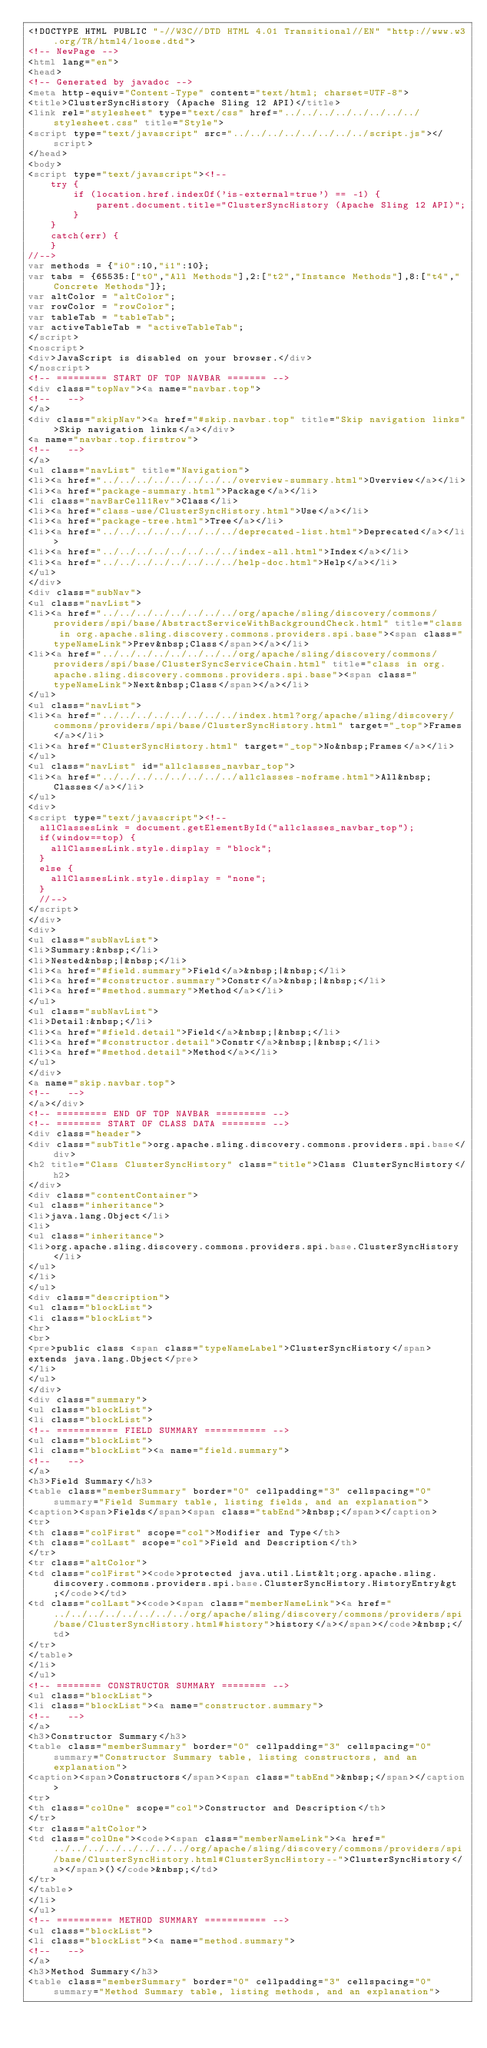<code> <loc_0><loc_0><loc_500><loc_500><_HTML_><!DOCTYPE HTML PUBLIC "-//W3C//DTD HTML 4.01 Transitional//EN" "http://www.w3.org/TR/html4/loose.dtd">
<!-- NewPage -->
<html lang="en">
<head>
<!-- Generated by javadoc -->
<meta http-equiv="Content-Type" content="text/html; charset=UTF-8">
<title>ClusterSyncHistory (Apache Sling 12 API)</title>
<link rel="stylesheet" type="text/css" href="../../../../../../../../stylesheet.css" title="Style">
<script type="text/javascript" src="../../../../../../../../script.js"></script>
</head>
<body>
<script type="text/javascript"><!--
    try {
        if (location.href.indexOf('is-external=true') == -1) {
            parent.document.title="ClusterSyncHistory (Apache Sling 12 API)";
        }
    }
    catch(err) {
    }
//-->
var methods = {"i0":10,"i1":10};
var tabs = {65535:["t0","All Methods"],2:["t2","Instance Methods"],8:["t4","Concrete Methods"]};
var altColor = "altColor";
var rowColor = "rowColor";
var tableTab = "tableTab";
var activeTableTab = "activeTableTab";
</script>
<noscript>
<div>JavaScript is disabled on your browser.</div>
</noscript>
<!-- ========= START OF TOP NAVBAR ======= -->
<div class="topNav"><a name="navbar.top">
<!--   -->
</a>
<div class="skipNav"><a href="#skip.navbar.top" title="Skip navigation links">Skip navigation links</a></div>
<a name="navbar.top.firstrow">
<!--   -->
</a>
<ul class="navList" title="Navigation">
<li><a href="../../../../../../../../overview-summary.html">Overview</a></li>
<li><a href="package-summary.html">Package</a></li>
<li class="navBarCell1Rev">Class</li>
<li><a href="class-use/ClusterSyncHistory.html">Use</a></li>
<li><a href="package-tree.html">Tree</a></li>
<li><a href="../../../../../../../../deprecated-list.html">Deprecated</a></li>
<li><a href="../../../../../../../../index-all.html">Index</a></li>
<li><a href="../../../../../../../../help-doc.html">Help</a></li>
</ul>
</div>
<div class="subNav">
<ul class="navList">
<li><a href="../../../../../../../../org/apache/sling/discovery/commons/providers/spi/base/AbstractServiceWithBackgroundCheck.html" title="class in org.apache.sling.discovery.commons.providers.spi.base"><span class="typeNameLink">Prev&nbsp;Class</span></a></li>
<li><a href="../../../../../../../../org/apache/sling/discovery/commons/providers/spi/base/ClusterSyncServiceChain.html" title="class in org.apache.sling.discovery.commons.providers.spi.base"><span class="typeNameLink">Next&nbsp;Class</span></a></li>
</ul>
<ul class="navList">
<li><a href="../../../../../../../../index.html?org/apache/sling/discovery/commons/providers/spi/base/ClusterSyncHistory.html" target="_top">Frames</a></li>
<li><a href="ClusterSyncHistory.html" target="_top">No&nbsp;Frames</a></li>
</ul>
<ul class="navList" id="allclasses_navbar_top">
<li><a href="../../../../../../../../allclasses-noframe.html">All&nbsp;Classes</a></li>
</ul>
<div>
<script type="text/javascript"><!--
  allClassesLink = document.getElementById("allclasses_navbar_top");
  if(window==top) {
    allClassesLink.style.display = "block";
  }
  else {
    allClassesLink.style.display = "none";
  }
  //-->
</script>
</div>
<div>
<ul class="subNavList">
<li>Summary:&nbsp;</li>
<li>Nested&nbsp;|&nbsp;</li>
<li><a href="#field.summary">Field</a>&nbsp;|&nbsp;</li>
<li><a href="#constructor.summary">Constr</a>&nbsp;|&nbsp;</li>
<li><a href="#method.summary">Method</a></li>
</ul>
<ul class="subNavList">
<li>Detail:&nbsp;</li>
<li><a href="#field.detail">Field</a>&nbsp;|&nbsp;</li>
<li><a href="#constructor.detail">Constr</a>&nbsp;|&nbsp;</li>
<li><a href="#method.detail">Method</a></li>
</ul>
</div>
<a name="skip.navbar.top">
<!--   -->
</a></div>
<!-- ========= END OF TOP NAVBAR ========= -->
<!-- ======== START OF CLASS DATA ======== -->
<div class="header">
<div class="subTitle">org.apache.sling.discovery.commons.providers.spi.base</div>
<h2 title="Class ClusterSyncHistory" class="title">Class ClusterSyncHistory</h2>
</div>
<div class="contentContainer">
<ul class="inheritance">
<li>java.lang.Object</li>
<li>
<ul class="inheritance">
<li>org.apache.sling.discovery.commons.providers.spi.base.ClusterSyncHistory</li>
</ul>
</li>
</ul>
<div class="description">
<ul class="blockList">
<li class="blockList">
<hr>
<br>
<pre>public class <span class="typeNameLabel">ClusterSyncHistory</span>
extends java.lang.Object</pre>
</li>
</ul>
</div>
<div class="summary">
<ul class="blockList">
<li class="blockList">
<!-- =========== FIELD SUMMARY =========== -->
<ul class="blockList">
<li class="blockList"><a name="field.summary">
<!--   -->
</a>
<h3>Field Summary</h3>
<table class="memberSummary" border="0" cellpadding="3" cellspacing="0" summary="Field Summary table, listing fields, and an explanation">
<caption><span>Fields</span><span class="tabEnd">&nbsp;</span></caption>
<tr>
<th class="colFirst" scope="col">Modifier and Type</th>
<th class="colLast" scope="col">Field and Description</th>
</tr>
<tr class="altColor">
<td class="colFirst"><code>protected java.util.List&lt;org.apache.sling.discovery.commons.providers.spi.base.ClusterSyncHistory.HistoryEntry&gt;</code></td>
<td class="colLast"><code><span class="memberNameLink"><a href="../../../../../../../../org/apache/sling/discovery/commons/providers/spi/base/ClusterSyncHistory.html#history">history</a></span></code>&nbsp;</td>
</tr>
</table>
</li>
</ul>
<!-- ======== CONSTRUCTOR SUMMARY ======== -->
<ul class="blockList">
<li class="blockList"><a name="constructor.summary">
<!--   -->
</a>
<h3>Constructor Summary</h3>
<table class="memberSummary" border="0" cellpadding="3" cellspacing="0" summary="Constructor Summary table, listing constructors, and an explanation">
<caption><span>Constructors</span><span class="tabEnd">&nbsp;</span></caption>
<tr>
<th class="colOne" scope="col">Constructor and Description</th>
</tr>
<tr class="altColor">
<td class="colOne"><code><span class="memberNameLink"><a href="../../../../../../../../org/apache/sling/discovery/commons/providers/spi/base/ClusterSyncHistory.html#ClusterSyncHistory--">ClusterSyncHistory</a></span>()</code>&nbsp;</td>
</tr>
</table>
</li>
</ul>
<!-- ========== METHOD SUMMARY =========== -->
<ul class="blockList">
<li class="blockList"><a name="method.summary">
<!--   -->
</a>
<h3>Method Summary</h3>
<table class="memberSummary" border="0" cellpadding="3" cellspacing="0" summary="Method Summary table, listing methods, and an explanation"></code> 